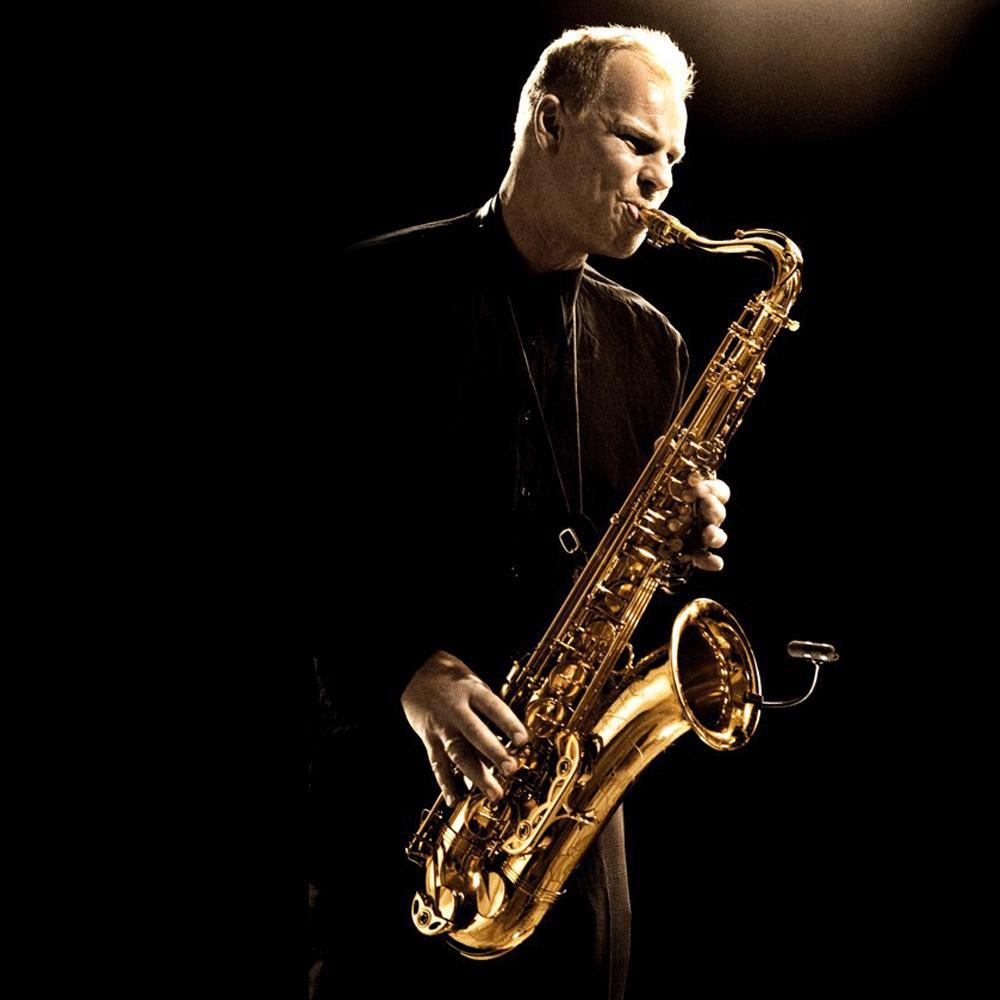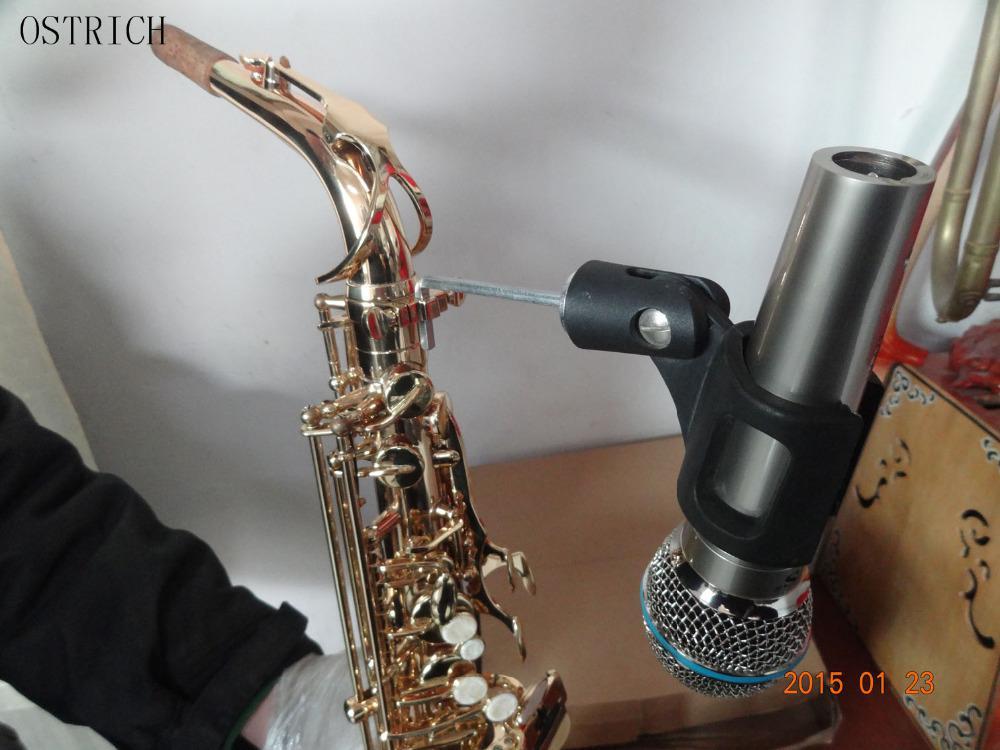The first image is the image on the left, the second image is the image on the right. Given the left and right images, does the statement "At least one image includes a rightward turned man in dark clothing standing and playing a saxophone." hold true? Answer yes or no. Yes. The first image is the image on the left, the second image is the image on the right. Given the left and right images, does the statement "A man is blowing into the mouthpiece of the saxophone." hold true? Answer yes or no. Yes. 